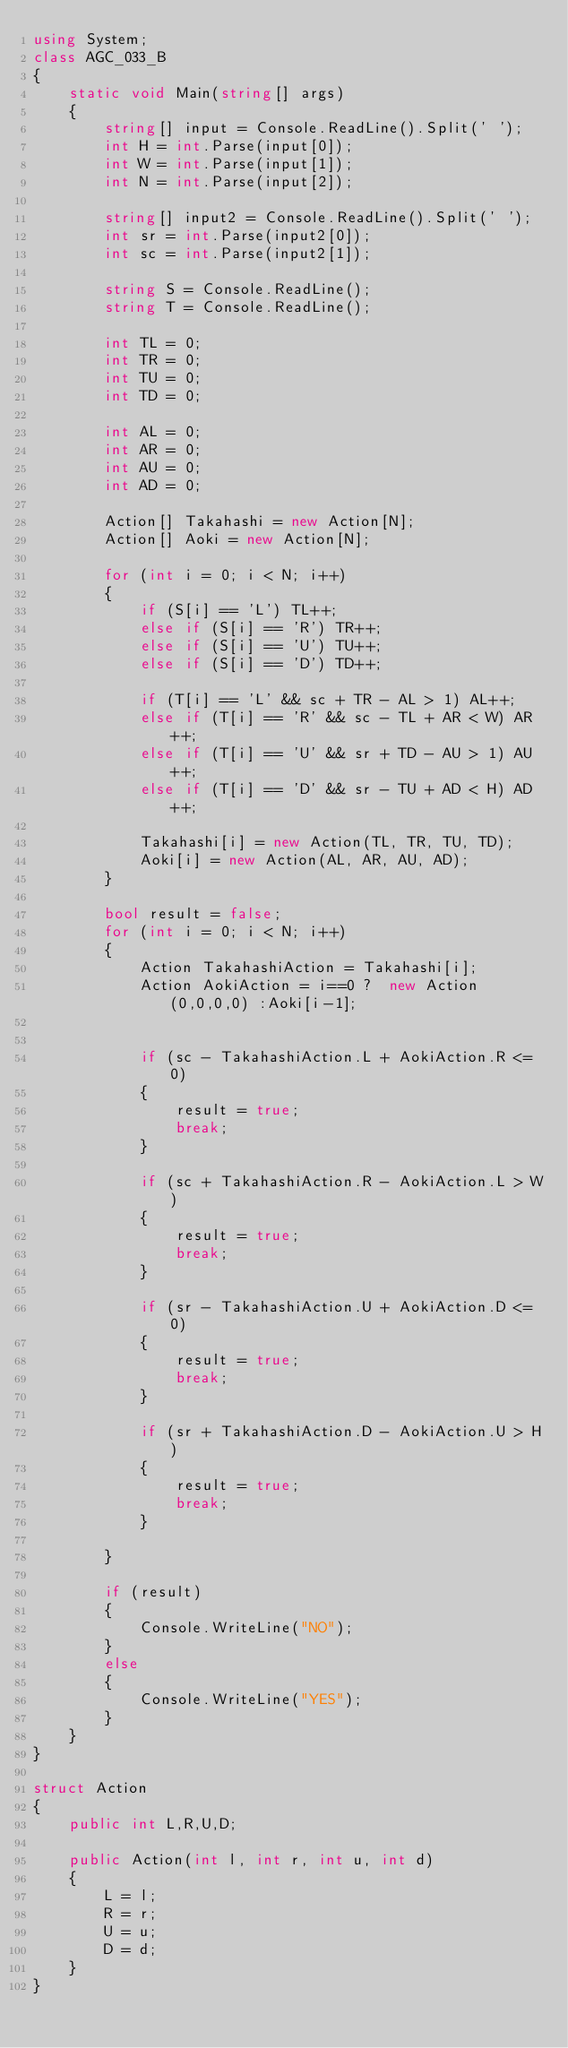<code> <loc_0><loc_0><loc_500><loc_500><_C#_>using System;
class AGC_033_B
{
    static void Main(string[] args)
    {
        string[] input = Console.ReadLine().Split(' ');
        int H = int.Parse(input[0]);
        int W = int.Parse(input[1]);
        int N = int.Parse(input[2]);

        string[] input2 = Console.ReadLine().Split(' ');
        int sr = int.Parse(input2[0]);
        int sc = int.Parse(input2[1]);

        string S = Console.ReadLine();
        string T = Console.ReadLine();

        int TL = 0;
        int TR = 0;
        int TU = 0;
        int TD = 0;

        int AL = 0;
        int AR = 0;
        int AU = 0;
        int AD = 0;

        Action[] Takahashi = new Action[N];
        Action[] Aoki = new Action[N];

        for (int i = 0; i < N; i++)
        {
            if (S[i] == 'L') TL++;
            else if (S[i] == 'R') TR++;
            else if (S[i] == 'U') TU++;
            else if (S[i] == 'D') TD++;

            if (T[i] == 'L' && sc + TR - AL > 1) AL++;
            else if (T[i] == 'R' && sc - TL + AR < W) AR++;
            else if (T[i] == 'U' && sr + TD - AU > 1) AU++;
            else if (T[i] == 'D' && sr - TU + AD < H) AD++;

            Takahashi[i] = new Action(TL, TR, TU, TD);
            Aoki[i] = new Action(AL, AR, AU, AD);
        }

        bool result = false;
        for (int i = 0; i < N; i++)
        {
            Action TakahashiAction = Takahashi[i];
            Action AokiAction = i==0 ?  new Action(0,0,0,0) :Aoki[i-1];


            if (sc - TakahashiAction.L + AokiAction.R <= 0)
            {
                result = true;
                break;
            }

            if (sc + TakahashiAction.R - AokiAction.L > W)
            {
                result = true;
                break;
            }

            if (sr - TakahashiAction.U + AokiAction.D <= 0)
            {
                result = true;
                break;
            }

            if (sr + TakahashiAction.D - AokiAction.U > H)
            {
                result = true;
                break;
            }

        }

        if (result)
        {
            Console.WriteLine("NO");
        }
        else
        {
            Console.WriteLine("YES");
        }
    }
}

struct Action
{
    public int L,R,U,D;

    public Action(int l, int r, int u, int d)
    {
        L = l;
        R = r;
        U = u;
        D = d;
    }
}</code> 